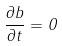<formula> <loc_0><loc_0><loc_500><loc_500>\frac { \partial b } { \partial t } = 0</formula> 